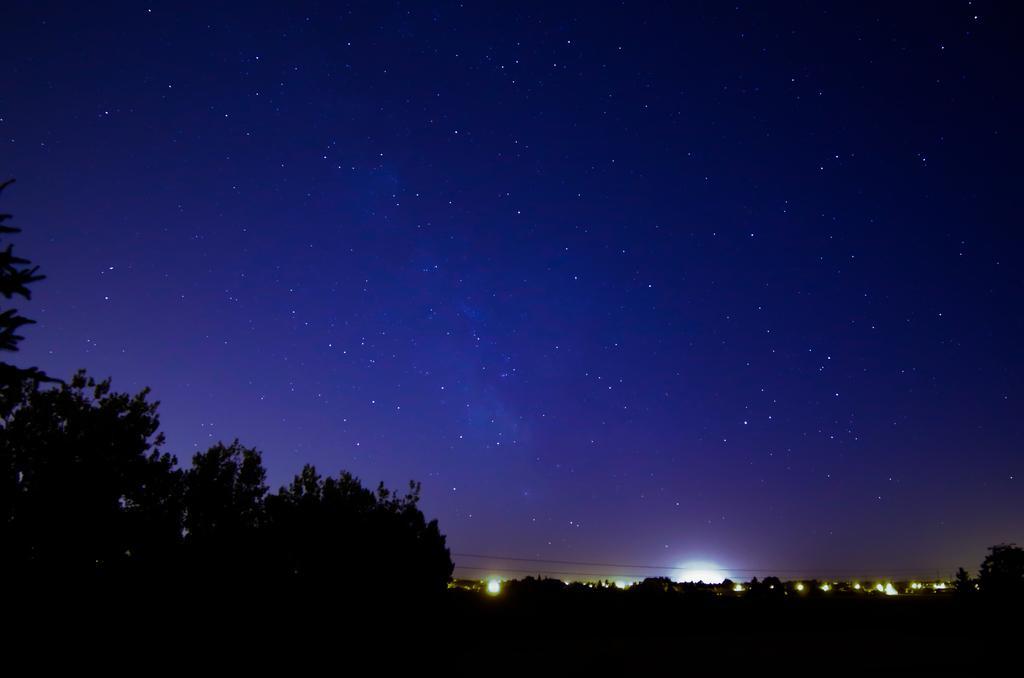Describe this image in one or two sentences. The image is taken during night time. At the bottom of the picture there are trees and lights. In this picture we can see sky, in the sky there are stars. 